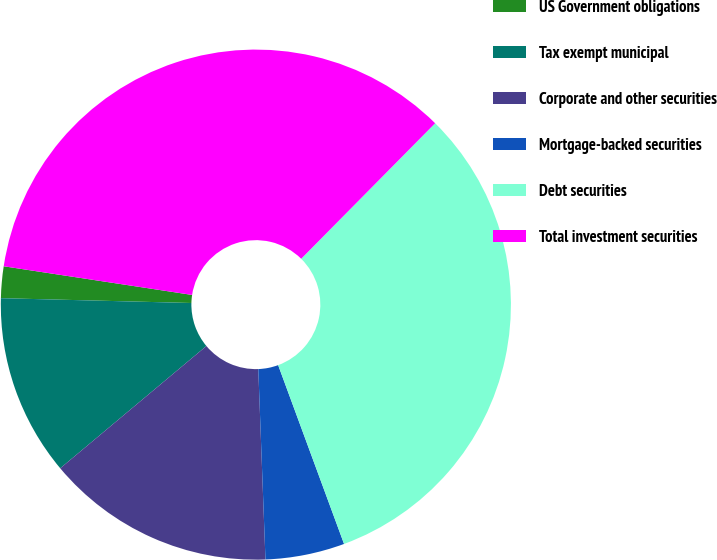<chart> <loc_0><loc_0><loc_500><loc_500><pie_chart><fcel>US Government obligations<fcel>Tax exempt municipal<fcel>Corporate and other securities<fcel>Mortgage-backed securities<fcel>Debt securities<fcel>Total investment securities<nl><fcel>2.0%<fcel>11.49%<fcel>14.51%<fcel>5.02%<fcel>31.97%<fcel>35.0%<nl></chart> 